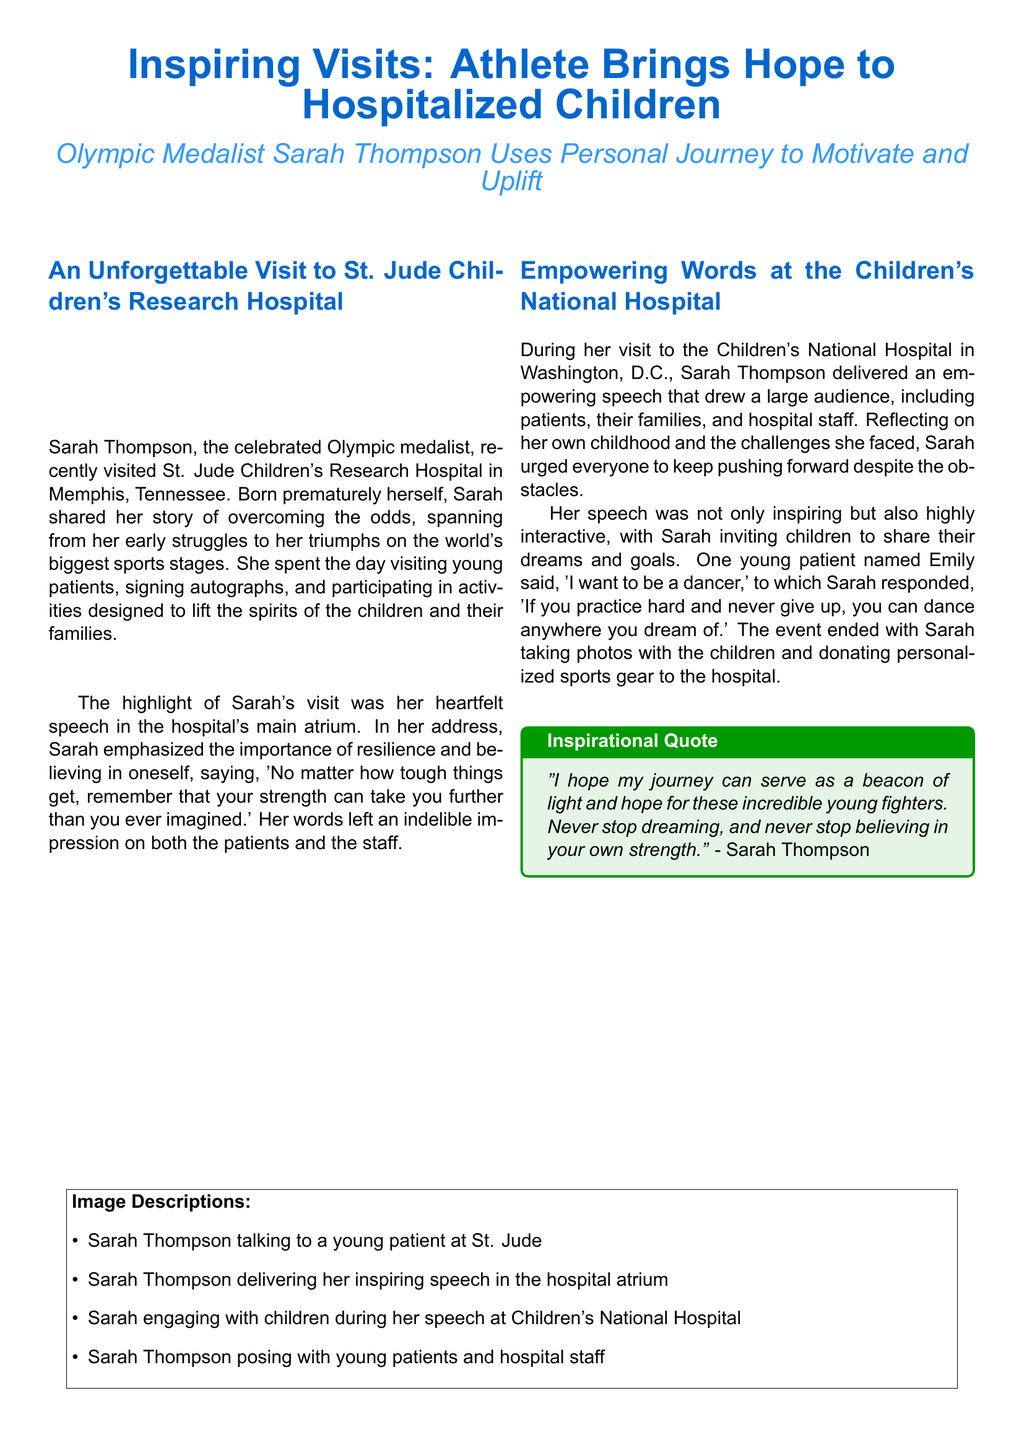What hospital did Sarah Thompson visit in Memphis? The document states that Sarah visited St. Jude Children's Research Hospital in Memphis, Tennessee.
Answer: St. Jude Children's Research Hospital What is the main theme of Sarah Thompson's speech? Sarah emphasized the importance of resilience and believing in oneself, as noted in her speech.
Answer: Resilience and believing in oneself What did young patient Emily want to be? Emily expressed her dream of becoming a dancer during Sarah's visit.
Answer: A dancer What type of items did Sarah donate to the hospital? The document mentions that Sarah donated personalized sports gear to the hospital during her visit.
Answer: Personalized sports gear How did Sarah engage with the children during her speech? Sarah invited children to share their dreams and goals, which shows her interactive approach during the speech.
Answer: Inviting children to share their dreams What inspirational quote is attributed to Sarah Thompson? The document includes a quote from Sarah about serving as a beacon of light and hope for young fighters.
Answer: "I hope my journey can serve as a beacon of light and hope for these incredible young fighters." What kind of activities did Sarah participate in at St. Jude? According to the document, Sarah participated in activities designed to lift the spirits of the children and their families.
Answer: Activities to lift spirits What color is used for the headline in the document? The headline color is specified as RGB(0,102,204) in the document, which is a shade of blue.
Answer: Blue How many hospitals did Sarah visit as mentioned in the document? The document recounts two hospital visits made by Sarah Thompson.
Answer: Two 